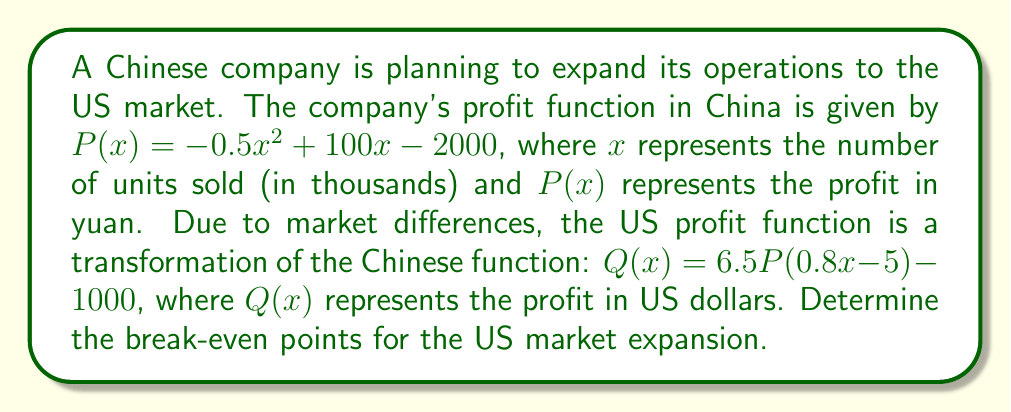Help me with this question. Let's approach this step-by-step:

1) First, we need to substitute the original function $P(x)$ into the transformation $Q(x)$:

   $Q(x) = 6.5(-0.5(0.8x - 5)^2 + 100(0.8x - 5) - 2000) - 1000$

2) Expand the squared term:
   
   $Q(x) = 6.5(-0.5(0.64x^2 - 8x + 25) + 80x - 500 - 2000) - 1000$

3) Simplify:

   $Q(x) = 6.5(-0.32x^2 + 4x - 12.5 + 80x - 500 - 2000) - 1000$
   $Q(x) = 6.5(-0.32x^2 + 84x - 2512.5) - 1000$

4) Distribute 6.5:

   $Q(x) = -2.08x^2 + 546x - 16331.25 - 1000$
   $Q(x) = -2.08x^2 + 546x - 17331.25$

5) To find the break-even points, we set $Q(x) = 0$:

   $-2.08x^2 + 546x - 17331.25 = 0$

6) This is a quadratic equation. We can solve it using the quadratic formula:
   $x = \frac{-b \pm \sqrt{b^2 - 4ac}}{2a}$

   Where $a = -2.08$, $b = 546$, and $c = -17331.25$

7) Plugging these values into the quadratic formula:

   $x = \frac{-546 \pm \sqrt{546^2 - 4(-2.08)(-17331.25)}}{2(-2.08)}$

8) Simplify:

   $x = \frac{-546 \pm \sqrt{298116 + 144164.8}}{-4.16}$
   $x = \frac{-546 \pm \sqrt{442280.8}}{-4.16}$
   $x = \frac{-546 \pm 665.04}{-4.16}$

9) This gives us two solutions:

   $x_1 = \frac{-546 + 665.04}{-4.16} \approx 28.62$
   $x_2 = \frac{-546 - 665.04}{-4.16} \approx 291.84$

Therefore, the break-even points are approximately 28,620 and 291,840 units.
Answer: 28,620 and 291,840 units 